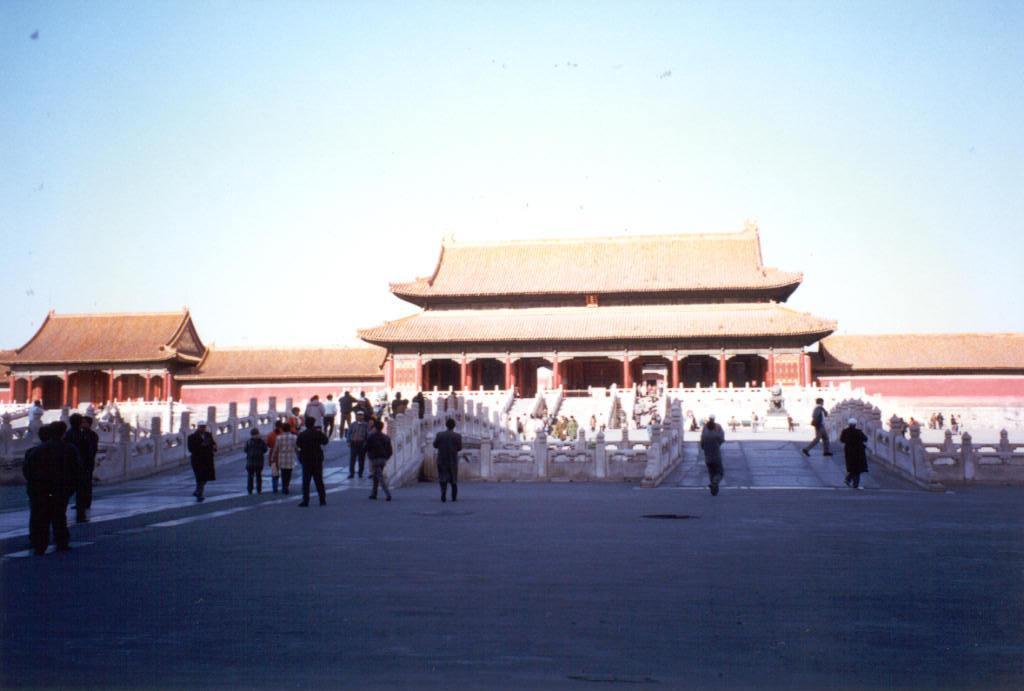Could you give a brief overview of what you see in this image? In this image there is a temple in the middle. In front of the temple there is a bridge on which there are people walking on it. At the top there is sky. 